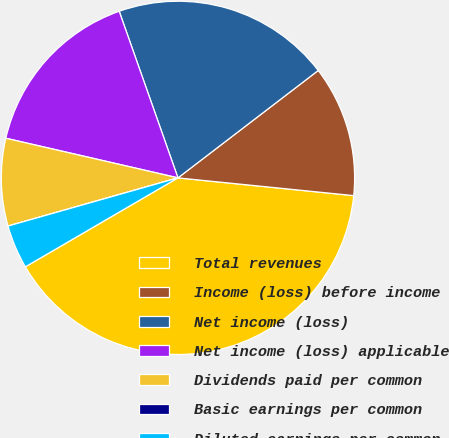Convert chart. <chart><loc_0><loc_0><loc_500><loc_500><pie_chart><fcel>Total revenues<fcel>Income (loss) before income<fcel>Net income (loss)<fcel>Net income (loss) applicable<fcel>Dividends paid per common<fcel>Basic earnings per common<fcel>Diluted earnings per common<nl><fcel>40.0%<fcel>12.0%<fcel>20.0%<fcel>16.0%<fcel>8.0%<fcel>0.0%<fcel>4.0%<nl></chart> 